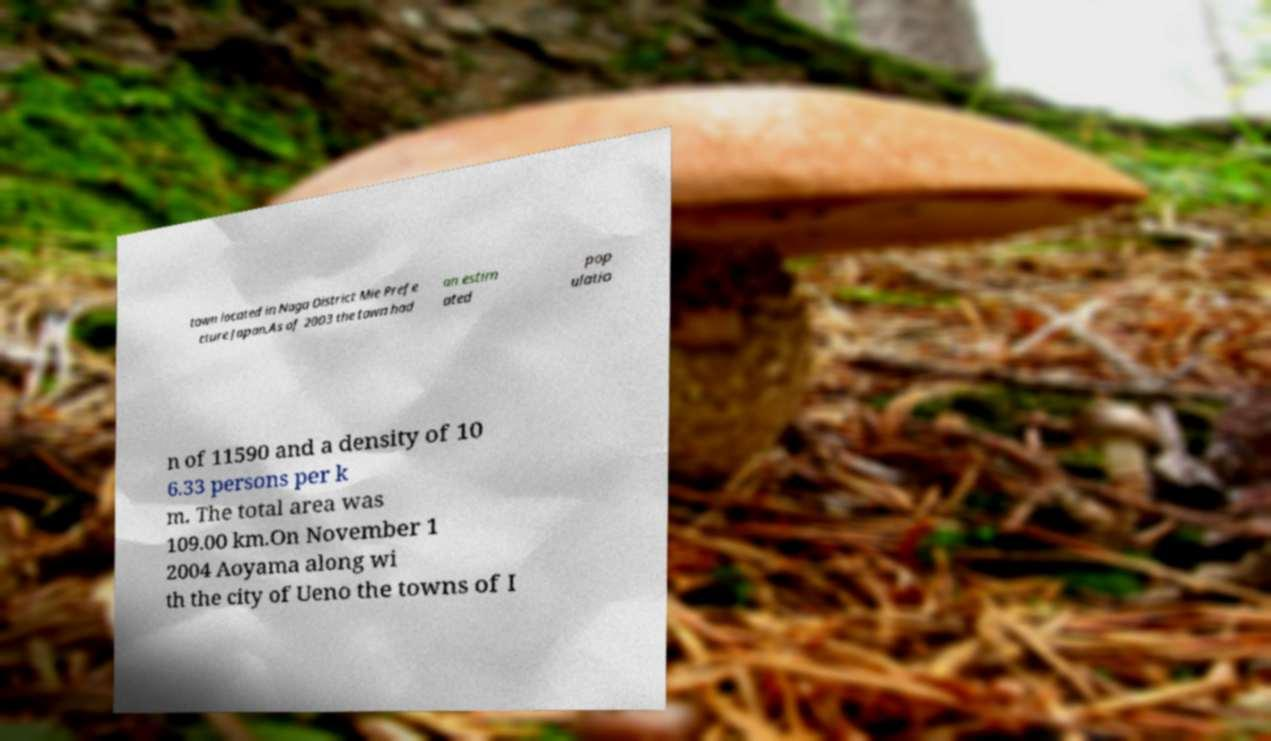Can you read and provide the text displayed in the image?This photo seems to have some interesting text. Can you extract and type it out for me? town located in Naga District Mie Prefe cture Japan.As of 2003 the town had an estim ated pop ulatio n of 11590 and a density of 10 6.33 persons per k m. The total area was 109.00 km.On November 1 2004 Aoyama along wi th the city of Ueno the towns of I 